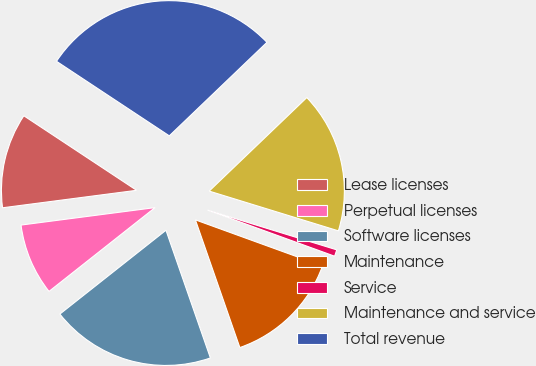Convert chart. <chart><loc_0><loc_0><loc_500><loc_500><pie_chart><fcel>Lease licenses<fcel>Perpetual licenses<fcel>Software licenses<fcel>Maintenance<fcel>Service<fcel>Maintenance and service<fcel>Total revenue<nl><fcel>11.36%<fcel>8.58%<fcel>19.69%<fcel>14.13%<fcel>0.79%<fcel>16.91%<fcel>28.55%<nl></chart> 